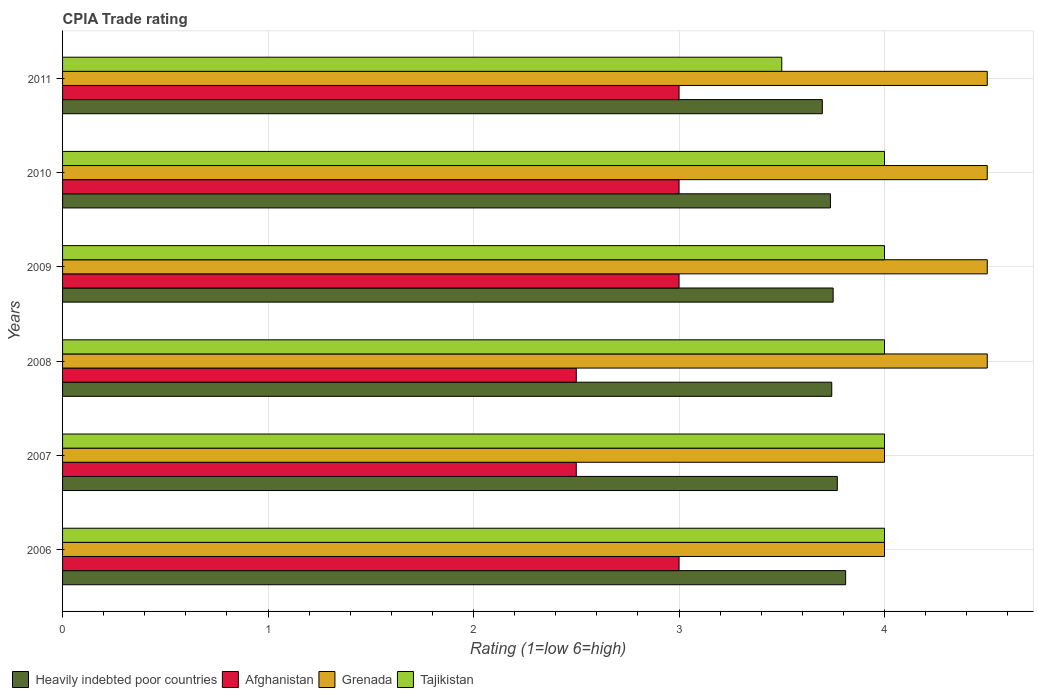How many different coloured bars are there?
Offer a very short reply. 4. How many groups of bars are there?
Your answer should be very brief. 6. Are the number of bars per tick equal to the number of legend labels?
Provide a succinct answer. Yes. How many bars are there on the 2nd tick from the top?
Your response must be concise. 4. What is the label of the 2nd group of bars from the top?
Give a very brief answer. 2010. In how many cases, is the number of bars for a given year not equal to the number of legend labels?
Your answer should be compact. 0. What is the CPIA rating in Tajikistan in 2011?
Your answer should be very brief. 3.5. Across all years, what is the maximum CPIA rating in Heavily indebted poor countries?
Give a very brief answer. 3.81. In which year was the CPIA rating in Afghanistan maximum?
Give a very brief answer. 2006. What is the total CPIA rating in Heavily indebted poor countries in the graph?
Your answer should be very brief. 22.51. What is the difference between the CPIA rating in Heavily indebted poor countries in 2010 and the CPIA rating in Tajikistan in 2011?
Your answer should be very brief. 0.24. What is the average CPIA rating in Heavily indebted poor countries per year?
Your answer should be compact. 3.75. In the year 2008, what is the difference between the CPIA rating in Afghanistan and CPIA rating in Grenada?
Your answer should be compact. -2. In how many years, is the CPIA rating in Tajikistan greater than 0.2 ?
Provide a short and direct response. 6. What is the ratio of the CPIA rating in Grenada in 2009 to that in 2010?
Keep it short and to the point. 1. Is the CPIA rating in Heavily indebted poor countries in 2006 less than that in 2010?
Your answer should be very brief. No. What is the difference between the highest and the second highest CPIA rating in Grenada?
Make the answer very short. 0. What is the difference between the highest and the lowest CPIA rating in Grenada?
Your answer should be compact. 0.5. In how many years, is the CPIA rating in Heavily indebted poor countries greater than the average CPIA rating in Heavily indebted poor countries taken over all years?
Your answer should be compact. 2. Is the sum of the CPIA rating in Heavily indebted poor countries in 2008 and 2010 greater than the maximum CPIA rating in Grenada across all years?
Give a very brief answer. Yes. Is it the case that in every year, the sum of the CPIA rating in Heavily indebted poor countries and CPIA rating in Afghanistan is greater than the sum of CPIA rating in Tajikistan and CPIA rating in Grenada?
Offer a very short reply. No. What does the 1st bar from the top in 2008 represents?
Make the answer very short. Tajikistan. What does the 2nd bar from the bottom in 2007 represents?
Ensure brevity in your answer.  Afghanistan. Is it the case that in every year, the sum of the CPIA rating in Afghanistan and CPIA rating in Grenada is greater than the CPIA rating in Heavily indebted poor countries?
Provide a short and direct response. Yes. How many bars are there?
Offer a terse response. 24. Are all the bars in the graph horizontal?
Your response must be concise. Yes. What is the difference between two consecutive major ticks on the X-axis?
Offer a very short reply. 1. Does the graph contain grids?
Provide a succinct answer. Yes. Where does the legend appear in the graph?
Your answer should be very brief. Bottom left. How are the legend labels stacked?
Keep it short and to the point. Horizontal. What is the title of the graph?
Offer a very short reply. CPIA Trade rating. What is the label or title of the X-axis?
Keep it short and to the point. Rating (1=low 6=high). What is the Rating (1=low 6=high) of Heavily indebted poor countries in 2006?
Your answer should be very brief. 3.81. What is the Rating (1=low 6=high) in Afghanistan in 2006?
Offer a very short reply. 3. What is the Rating (1=low 6=high) in Grenada in 2006?
Offer a very short reply. 4. What is the Rating (1=low 6=high) of Tajikistan in 2006?
Offer a terse response. 4. What is the Rating (1=low 6=high) in Heavily indebted poor countries in 2007?
Ensure brevity in your answer.  3.77. What is the Rating (1=low 6=high) of Grenada in 2007?
Provide a short and direct response. 4. What is the Rating (1=low 6=high) in Heavily indebted poor countries in 2008?
Give a very brief answer. 3.74. What is the Rating (1=low 6=high) of Heavily indebted poor countries in 2009?
Ensure brevity in your answer.  3.75. What is the Rating (1=low 6=high) of Afghanistan in 2009?
Your answer should be very brief. 3. What is the Rating (1=low 6=high) of Grenada in 2009?
Make the answer very short. 4.5. What is the Rating (1=low 6=high) of Heavily indebted poor countries in 2010?
Ensure brevity in your answer.  3.74. What is the Rating (1=low 6=high) of Afghanistan in 2010?
Offer a terse response. 3. What is the Rating (1=low 6=high) in Tajikistan in 2010?
Your answer should be very brief. 4. What is the Rating (1=low 6=high) in Heavily indebted poor countries in 2011?
Your answer should be compact. 3.7. What is the Rating (1=low 6=high) of Afghanistan in 2011?
Offer a terse response. 3. What is the Rating (1=low 6=high) in Grenada in 2011?
Offer a very short reply. 4.5. Across all years, what is the maximum Rating (1=low 6=high) of Heavily indebted poor countries?
Give a very brief answer. 3.81. Across all years, what is the minimum Rating (1=low 6=high) in Heavily indebted poor countries?
Your answer should be very brief. 3.7. Across all years, what is the minimum Rating (1=low 6=high) of Afghanistan?
Make the answer very short. 2.5. Across all years, what is the minimum Rating (1=low 6=high) of Tajikistan?
Ensure brevity in your answer.  3.5. What is the total Rating (1=low 6=high) of Heavily indebted poor countries in the graph?
Give a very brief answer. 22.51. What is the total Rating (1=low 6=high) in Grenada in the graph?
Offer a very short reply. 26. What is the difference between the Rating (1=low 6=high) in Heavily indebted poor countries in 2006 and that in 2007?
Provide a short and direct response. 0.04. What is the difference between the Rating (1=low 6=high) of Tajikistan in 2006 and that in 2007?
Provide a succinct answer. 0. What is the difference between the Rating (1=low 6=high) of Heavily indebted poor countries in 2006 and that in 2008?
Offer a terse response. 0.07. What is the difference between the Rating (1=low 6=high) in Grenada in 2006 and that in 2008?
Make the answer very short. -0.5. What is the difference between the Rating (1=low 6=high) in Heavily indebted poor countries in 2006 and that in 2009?
Your response must be concise. 0.06. What is the difference between the Rating (1=low 6=high) of Grenada in 2006 and that in 2009?
Your response must be concise. -0.5. What is the difference between the Rating (1=low 6=high) in Heavily indebted poor countries in 2006 and that in 2010?
Your response must be concise. 0.07. What is the difference between the Rating (1=low 6=high) of Afghanistan in 2006 and that in 2010?
Keep it short and to the point. 0. What is the difference between the Rating (1=low 6=high) of Heavily indebted poor countries in 2006 and that in 2011?
Offer a terse response. 0.11. What is the difference between the Rating (1=low 6=high) of Tajikistan in 2006 and that in 2011?
Give a very brief answer. 0.5. What is the difference between the Rating (1=low 6=high) in Heavily indebted poor countries in 2007 and that in 2008?
Offer a very short reply. 0.03. What is the difference between the Rating (1=low 6=high) of Tajikistan in 2007 and that in 2008?
Your answer should be very brief. 0. What is the difference between the Rating (1=low 6=high) in Heavily indebted poor countries in 2007 and that in 2009?
Your answer should be compact. 0.02. What is the difference between the Rating (1=low 6=high) of Tajikistan in 2007 and that in 2009?
Make the answer very short. 0. What is the difference between the Rating (1=low 6=high) of Heavily indebted poor countries in 2007 and that in 2010?
Your answer should be compact. 0.03. What is the difference between the Rating (1=low 6=high) in Afghanistan in 2007 and that in 2010?
Offer a very short reply. -0.5. What is the difference between the Rating (1=low 6=high) of Grenada in 2007 and that in 2010?
Offer a terse response. -0.5. What is the difference between the Rating (1=low 6=high) in Heavily indebted poor countries in 2007 and that in 2011?
Ensure brevity in your answer.  0.07. What is the difference between the Rating (1=low 6=high) of Heavily indebted poor countries in 2008 and that in 2009?
Keep it short and to the point. -0.01. What is the difference between the Rating (1=low 6=high) in Tajikistan in 2008 and that in 2009?
Ensure brevity in your answer.  0. What is the difference between the Rating (1=low 6=high) of Heavily indebted poor countries in 2008 and that in 2010?
Offer a very short reply. 0.01. What is the difference between the Rating (1=low 6=high) in Afghanistan in 2008 and that in 2010?
Give a very brief answer. -0.5. What is the difference between the Rating (1=low 6=high) of Tajikistan in 2008 and that in 2010?
Keep it short and to the point. 0. What is the difference between the Rating (1=low 6=high) of Heavily indebted poor countries in 2008 and that in 2011?
Offer a terse response. 0.05. What is the difference between the Rating (1=low 6=high) of Grenada in 2008 and that in 2011?
Keep it short and to the point. 0. What is the difference between the Rating (1=low 6=high) in Tajikistan in 2008 and that in 2011?
Your response must be concise. 0.5. What is the difference between the Rating (1=low 6=high) of Heavily indebted poor countries in 2009 and that in 2010?
Provide a succinct answer. 0.01. What is the difference between the Rating (1=low 6=high) of Afghanistan in 2009 and that in 2010?
Offer a very short reply. 0. What is the difference between the Rating (1=low 6=high) of Grenada in 2009 and that in 2010?
Give a very brief answer. 0. What is the difference between the Rating (1=low 6=high) of Heavily indebted poor countries in 2009 and that in 2011?
Offer a very short reply. 0.05. What is the difference between the Rating (1=low 6=high) of Grenada in 2009 and that in 2011?
Give a very brief answer. 0. What is the difference between the Rating (1=low 6=high) in Tajikistan in 2009 and that in 2011?
Make the answer very short. 0.5. What is the difference between the Rating (1=low 6=high) of Heavily indebted poor countries in 2010 and that in 2011?
Your answer should be compact. 0.04. What is the difference between the Rating (1=low 6=high) of Heavily indebted poor countries in 2006 and the Rating (1=low 6=high) of Afghanistan in 2007?
Offer a terse response. 1.31. What is the difference between the Rating (1=low 6=high) of Heavily indebted poor countries in 2006 and the Rating (1=low 6=high) of Grenada in 2007?
Your answer should be compact. -0.19. What is the difference between the Rating (1=low 6=high) of Heavily indebted poor countries in 2006 and the Rating (1=low 6=high) of Tajikistan in 2007?
Make the answer very short. -0.19. What is the difference between the Rating (1=low 6=high) of Afghanistan in 2006 and the Rating (1=low 6=high) of Tajikistan in 2007?
Your answer should be compact. -1. What is the difference between the Rating (1=low 6=high) of Grenada in 2006 and the Rating (1=low 6=high) of Tajikistan in 2007?
Keep it short and to the point. 0. What is the difference between the Rating (1=low 6=high) in Heavily indebted poor countries in 2006 and the Rating (1=low 6=high) in Afghanistan in 2008?
Your answer should be very brief. 1.31. What is the difference between the Rating (1=low 6=high) in Heavily indebted poor countries in 2006 and the Rating (1=low 6=high) in Grenada in 2008?
Your answer should be very brief. -0.69. What is the difference between the Rating (1=low 6=high) in Heavily indebted poor countries in 2006 and the Rating (1=low 6=high) in Tajikistan in 2008?
Keep it short and to the point. -0.19. What is the difference between the Rating (1=low 6=high) of Afghanistan in 2006 and the Rating (1=low 6=high) of Tajikistan in 2008?
Your answer should be compact. -1. What is the difference between the Rating (1=low 6=high) of Heavily indebted poor countries in 2006 and the Rating (1=low 6=high) of Afghanistan in 2009?
Your answer should be compact. 0.81. What is the difference between the Rating (1=low 6=high) in Heavily indebted poor countries in 2006 and the Rating (1=low 6=high) in Grenada in 2009?
Ensure brevity in your answer.  -0.69. What is the difference between the Rating (1=low 6=high) of Heavily indebted poor countries in 2006 and the Rating (1=low 6=high) of Tajikistan in 2009?
Keep it short and to the point. -0.19. What is the difference between the Rating (1=low 6=high) in Afghanistan in 2006 and the Rating (1=low 6=high) in Grenada in 2009?
Offer a terse response. -1.5. What is the difference between the Rating (1=low 6=high) in Afghanistan in 2006 and the Rating (1=low 6=high) in Tajikistan in 2009?
Make the answer very short. -1. What is the difference between the Rating (1=low 6=high) in Grenada in 2006 and the Rating (1=low 6=high) in Tajikistan in 2009?
Make the answer very short. 0. What is the difference between the Rating (1=low 6=high) in Heavily indebted poor countries in 2006 and the Rating (1=low 6=high) in Afghanistan in 2010?
Offer a terse response. 0.81. What is the difference between the Rating (1=low 6=high) in Heavily indebted poor countries in 2006 and the Rating (1=low 6=high) in Grenada in 2010?
Provide a succinct answer. -0.69. What is the difference between the Rating (1=low 6=high) in Heavily indebted poor countries in 2006 and the Rating (1=low 6=high) in Tajikistan in 2010?
Offer a very short reply. -0.19. What is the difference between the Rating (1=low 6=high) in Heavily indebted poor countries in 2006 and the Rating (1=low 6=high) in Afghanistan in 2011?
Keep it short and to the point. 0.81. What is the difference between the Rating (1=low 6=high) in Heavily indebted poor countries in 2006 and the Rating (1=low 6=high) in Grenada in 2011?
Ensure brevity in your answer.  -0.69. What is the difference between the Rating (1=low 6=high) in Heavily indebted poor countries in 2006 and the Rating (1=low 6=high) in Tajikistan in 2011?
Your answer should be compact. 0.31. What is the difference between the Rating (1=low 6=high) in Afghanistan in 2006 and the Rating (1=low 6=high) in Tajikistan in 2011?
Make the answer very short. -0.5. What is the difference between the Rating (1=low 6=high) of Heavily indebted poor countries in 2007 and the Rating (1=low 6=high) of Afghanistan in 2008?
Ensure brevity in your answer.  1.27. What is the difference between the Rating (1=low 6=high) of Heavily indebted poor countries in 2007 and the Rating (1=low 6=high) of Grenada in 2008?
Your answer should be very brief. -0.73. What is the difference between the Rating (1=low 6=high) of Heavily indebted poor countries in 2007 and the Rating (1=low 6=high) of Tajikistan in 2008?
Keep it short and to the point. -0.23. What is the difference between the Rating (1=low 6=high) in Afghanistan in 2007 and the Rating (1=low 6=high) in Grenada in 2008?
Provide a short and direct response. -2. What is the difference between the Rating (1=low 6=high) of Heavily indebted poor countries in 2007 and the Rating (1=low 6=high) of Afghanistan in 2009?
Provide a short and direct response. 0.77. What is the difference between the Rating (1=low 6=high) of Heavily indebted poor countries in 2007 and the Rating (1=low 6=high) of Grenada in 2009?
Your answer should be compact. -0.73. What is the difference between the Rating (1=low 6=high) of Heavily indebted poor countries in 2007 and the Rating (1=low 6=high) of Tajikistan in 2009?
Your answer should be compact. -0.23. What is the difference between the Rating (1=low 6=high) in Heavily indebted poor countries in 2007 and the Rating (1=low 6=high) in Afghanistan in 2010?
Provide a succinct answer. 0.77. What is the difference between the Rating (1=low 6=high) of Heavily indebted poor countries in 2007 and the Rating (1=low 6=high) of Grenada in 2010?
Make the answer very short. -0.73. What is the difference between the Rating (1=low 6=high) of Heavily indebted poor countries in 2007 and the Rating (1=low 6=high) of Tajikistan in 2010?
Provide a short and direct response. -0.23. What is the difference between the Rating (1=low 6=high) in Afghanistan in 2007 and the Rating (1=low 6=high) in Tajikistan in 2010?
Your response must be concise. -1.5. What is the difference between the Rating (1=low 6=high) in Heavily indebted poor countries in 2007 and the Rating (1=low 6=high) in Afghanistan in 2011?
Your answer should be compact. 0.77. What is the difference between the Rating (1=low 6=high) in Heavily indebted poor countries in 2007 and the Rating (1=low 6=high) in Grenada in 2011?
Your answer should be compact. -0.73. What is the difference between the Rating (1=low 6=high) of Heavily indebted poor countries in 2007 and the Rating (1=low 6=high) of Tajikistan in 2011?
Provide a short and direct response. 0.27. What is the difference between the Rating (1=low 6=high) of Afghanistan in 2007 and the Rating (1=low 6=high) of Tajikistan in 2011?
Give a very brief answer. -1. What is the difference between the Rating (1=low 6=high) in Grenada in 2007 and the Rating (1=low 6=high) in Tajikistan in 2011?
Give a very brief answer. 0.5. What is the difference between the Rating (1=low 6=high) in Heavily indebted poor countries in 2008 and the Rating (1=low 6=high) in Afghanistan in 2009?
Your answer should be compact. 0.74. What is the difference between the Rating (1=low 6=high) in Heavily indebted poor countries in 2008 and the Rating (1=low 6=high) in Grenada in 2009?
Offer a very short reply. -0.76. What is the difference between the Rating (1=low 6=high) in Heavily indebted poor countries in 2008 and the Rating (1=low 6=high) in Tajikistan in 2009?
Your answer should be very brief. -0.26. What is the difference between the Rating (1=low 6=high) in Afghanistan in 2008 and the Rating (1=low 6=high) in Grenada in 2009?
Your answer should be very brief. -2. What is the difference between the Rating (1=low 6=high) of Afghanistan in 2008 and the Rating (1=low 6=high) of Tajikistan in 2009?
Provide a short and direct response. -1.5. What is the difference between the Rating (1=low 6=high) in Heavily indebted poor countries in 2008 and the Rating (1=low 6=high) in Afghanistan in 2010?
Give a very brief answer. 0.74. What is the difference between the Rating (1=low 6=high) of Heavily indebted poor countries in 2008 and the Rating (1=low 6=high) of Grenada in 2010?
Make the answer very short. -0.76. What is the difference between the Rating (1=low 6=high) of Heavily indebted poor countries in 2008 and the Rating (1=low 6=high) of Tajikistan in 2010?
Offer a very short reply. -0.26. What is the difference between the Rating (1=low 6=high) in Afghanistan in 2008 and the Rating (1=low 6=high) in Grenada in 2010?
Make the answer very short. -2. What is the difference between the Rating (1=low 6=high) of Heavily indebted poor countries in 2008 and the Rating (1=low 6=high) of Afghanistan in 2011?
Offer a very short reply. 0.74. What is the difference between the Rating (1=low 6=high) of Heavily indebted poor countries in 2008 and the Rating (1=low 6=high) of Grenada in 2011?
Keep it short and to the point. -0.76. What is the difference between the Rating (1=low 6=high) of Heavily indebted poor countries in 2008 and the Rating (1=low 6=high) of Tajikistan in 2011?
Ensure brevity in your answer.  0.24. What is the difference between the Rating (1=low 6=high) of Afghanistan in 2008 and the Rating (1=low 6=high) of Grenada in 2011?
Ensure brevity in your answer.  -2. What is the difference between the Rating (1=low 6=high) in Heavily indebted poor countries in 2009 and the Rating (1=low 6=high) in Grenada in 2010?
Make the answer very short. -0.75. What is the difference between the Rating (1=low 6=high) of Heavily indebted poor countries in 2009 and the Rating (1=low 6=high) of Tajikistan in 2010?
Your answer should be compact. -0.25. What is the difference between the Rating (1=low 6=high) of Afghanistan in 2009 and the Rating (1=low 6=high) of Tajikistan in 2010?
Make the answer very short. -1. What is the difference between the Rating (1=low 6=high) of Grenada in 2009 and the Rating (1=low 6=high) of Tajikistan in 2010?
Ensure brevity in your answer.  0.5. What is the difference between the Rating (1=low 6=high) in Heavily indebted poor countries in 2009 and the Rating (1=low 6=high) in Afghanistan in 2011?
Your answer should be very brief. 0.75. What is the difference between the Rating (1=low 6=high) of Heavily indebted poor countries in 2009 and the Rating (1=low 6=high) of Grenada in 2011?
Your answer should be very brief. -0.75. What is the difference between the Rating (1=low 6=high) in Heavily indebted poor countries in 2009 and the Rating (1=low 6=high) in Tajikistan in 2011?
Offer a very short reply. 0.25. What is the difference between the Rating (1=low 6=high) of Grenada in 2009 and the Rating (1=low 6=high) of Tajikistan in 2011?
Give a very brief answer. 1. What is the difference between the Rating (1=low 6=high) in Heavily indebted poor countries in 2010 and the Rating (1=low 6=high) in Afghanistan in 2011?
Make the answer very short. 0.74. What is the difference between the Rating (1=low 6=high) in Heavily indebted poor countries in 2010 and the Rating (1=low 6=high) in Grenada in 2011?
Your response must be concise. -0.76. What is the difference between the Rating (1=low 6=high) in Heavily indebted poor countries in 2010 and the Rating (1=low 6=high) in Tajikistan in 2011?
Offer a very short reply. 0.24. What is the difference between the Rating (1=low 6=high) of Afghanistan in 2010 and the Rating (1=low 6=high) of Tajikistan in 2011?
Keep it short and to the point. -0.5. What is the difference between the Rating (1=low 6=high) in Grenada in 2010 and the Rating (1=low 6=high) in Tajikistan in 2011?
Make the answer very short. 1. What is the average Rating (1=low 6=high) in Heavily indebted poor countries per year?
Give a very brief answer. 3.75. What is the average Rating (1=low 6=high) in Afghanistan per year?
Ensure brevity in your answer.  2.83. What is the average Rating (1=low 6=high) of Grenada per year?
Provide a short and direct response. 4.33. What is the average Rating (1=low 6=high) of Tajikistan per year?
Your answer should be very brief. 3.92. In the year 2006, what is the difference between the Rating (1=low 6=high) of Heavily indebted poor countries and Rating (1=low 6=high) of Afghanistan?
Make the answer very short. 0.81. In the year 2006, what is the difference between the Rating (1=low 6=high) of Heavily indebted poor countries and Rating (1=low 6=high) of Grenada?
Provide a succinct answer. -0.19. In the year 2006, what is the difference between the Rating (1=low 6=high) of Heavily indebted poor countries and Rating (1=low 6=high) of Tajikistan?
Your response must be concise. -0.19. In the year 2006, what is the difference between the Rating (1=low 6=high) of Afghanistan and Rating (1=low 6=high) of Tajikistan?
Make the answer very short. -1. In the year 2007, what is the difference between the Rating (1=low 6=high) in Heavily indebted poor countries and Rating (1=low 6=high) in Afghanistan?
Keep it short and to the point. 1.27. In the year 2007, what is the difference between the Rating (1=low 6=high) of Heavily indebted poor countries and Rating (1=low 6=high) of Grenada?
Provide a succinct answer. -0.23. In the year 2007, what is the difference between the Rating (1=low 6=high) of Heavily indebted poor countries and Rating (1=low 6=high) of Tajikistan?
Make the answer very short. -0.23. In the year 2007, what is the difference between the Rating (1=low 6=high) of Afghanistan and Rating (1=low 6=high) of Tajikistan?
Provide a succinct answer. -1.5. In the year 2007, what is the difference between the Rating (1=low 6=high) of Grenada and Rating (1=low 6=high) of Tajikistan?
Make the answer very short. 0. In the year 2008, what is the difference between the Rating (1=low 6=high) in Heavily indebted poor countries and Rating (1=low 6=high) in Afghanistan?
Ensure brevity in your answer.  1.24. In the year 2008, what is the difference between the Rating (1=low 6=high) in Heavily indebted poor countries and Rating (1=low 6=high) in Grenada?
Offer a very short reply. -0.76. In the year 2008, what is the difference between the Rating (1=low 6=high) in Heavily indebted poor countries and Rating (1=low 6=high) in Tajikistan?
Offer a terse response. -0.26. In the year 2009, what is the difference between the Rating (1=low 6=high) in Heavily indebted poor countries and Rating (1=low 6=high) in Grenada?
Keep it short and to the point. -0.75. In the year 2009, what is the difference between the Rating (1=low 6=high) in Heavily indebted poor countries and Rating (1=low 6=high) in Tajikistan?
Keep it short and to the point. -0.25. In the year 2009, what is the difference between the Rating (1=low 6=high) of Afghanistan and Rating (1=low 6=high) of Grenada?
Your answer should be very brief. -1.5. In the year 2009, what is the difference between the Rating (1=low 6=high) of Afghanistan and Rating (1=low 6=high) of Tajikistan?
Your answer should be very brief. -1. In the year 2010, what is the difference between the Rating (1=low 6=high) in Heavily indebted poor countries and Rating (1=low 6=high) in Afghanistan?
Offer a very short reply. 0.74. In the year 2010, what is the difference between the Rating (1=low 6=high) in Heavily indebted poor countries and Rating (1=low 6=high) in Grenada?
Offer a very short reply. -0.76. In the year 2010, what is the difference between the Rating (1=low 6=high) in Heavily indebted poor countries and Rating (1=low 6=high) in Tajikistan?
Keep it short and to the point. -0.26. In the year 2010, what is the difference between the Rating (1=low 6=high) of Afghanistan and Rating (1=low 6=high) of Grenada?
Your answer should be very brief. -1.5. In the year 2011, what is the difference between the Rating (1=low 6=high) of Heavily indebted poor countries and Rating (1=low 6=high) of Afghanistan?
Make the answer very short. 0.7. In the year 2011, what is the difference between the Rating (1=low 6=high) of Heavily indebted poor countries and Rating (1=low 6=high) of Grenada?
Offer a terse response. -0.8. In the year 2011, what is the difference between the Rating (1=low 6=high) in Heavily indebted poor countries and Rating (1=low 6=high) in Tajikistan?
Provide a succinct answer. 0.2. In the year 2011, what is the difference between the Rating (1=low 6=high) of Afghanistan and Rating (1=low 6=high) of Tajikistan?
Ensure brevity in your answer.  -0.5. What is the ratio of the Rating (1=low 6=high) of Heavily indebted poor countries in 2006 to that in 2007?
Provide a succinct answer. 1.01. What is the ratio of the Rating (1=low 6=high) in Afghanistan in 2006 to that in 2007?
Ensure brevity in your answer.  1.2. What is the ratio of the Rating (1=low 6=high) in Tajikistan in 2006 to that in 2007?
Your answer should be compact. 1. What is the ratio of the Rating (1=low 6=high) of Heavily indebted poor countries in 2006 to that in 2008?
Keep it short and to the point. 1.02. What is the ratio of the Rating (1=low 6=high) in Heavily indebted poor countries in 2006 to that in 2009?
Your answer should be compact. 1.02. What is the ratio of the Rating (1=low 6=high) of Afghanistan in 2006 to that in 2009?
Keep it short and to the point. 1. What is the ratio of the Rating (1=low 6=high) of Grenada in 2006 to that in 2009?
Your answer should be very brief. 0.89. What is the ratio of the Rating (1=low 6=high) in Tajikistan in 2006 to that in 2009?
Make the answer very short. 1. What is the ratio of the Rating (1=low 6=high) in Heavily indebted poor countries in 2006 to that in 2010?
Ensure brevity in your answer.  1.02. What is the ratio of the Rating (1=low 6=high) of Grenada in 2006 to that in 2010?
Give a very brief answer. 0.89. What is the ratio of the Rating (1=low 6=high) in Heavily indebted poor countries in 2006 to that in 2011?
Keep it short and to the point. 1.03. What is the ratio of the Rating (1=low 6=high) of Grenada in 2006 to that in 2011?
Offer a very short reply. 0.89. What is the ratio of the Rating (1=low 6=high) in Tajikistan in 2006 to that in 2011?
Your answer should be compact. 1.14. What is the ratio of the Rating (1=low 6=high) of Grenada in 2007 to that in 2008?
Your answer should be very brief. 0.89. What is the ratio of the Rating (1=low 6=high) in Heavily indebted poor countries in 2007 to that in 2009?
Keep it short and to the point. 1.01. What is the ratio of the Rating (1=low 6=high) of Afghanistan in 2007 to that in 2009?
Give a very brief answer. 0.83. What is the ratio of the Rating (1=low 6=high) in Tajikistan in 2007 to that in 2009?
Your answer should be compact. 1. What is the ratio of the Rating (1=low 6=high) in Heavily indebted poor countries in 2007 to that in 2010?
Provide a short and direct response. 1.01. What is the ratio of the Rating (1=low 6=high) of Heavily indebted poor countries in 2007 to that in 2011?
Ensure brevity in your answer.  1.02. What is the ratio of the Rating (1=low 6=high) in Afghanistan in 2007 to that in 2011?
Your response must be concise. 0.83. What is the ratio of the Rating (1=low 6=high) of Grenada in 2008 to that in 2009?
Your response must be concise. 1. What is the ratio of the Rating (1=low 6=high) in Tajikistan in 2008 to that in 2009?
Your response must be concise. 1. What is the ratio of the Rating (1=low 6=high) of Grenada in 2008 to that in 2010?
Make the answer very short. 1. What is the ratio of the Rating (1=low 6=high) in Tajikistan in 2008 to that in 2010?
Your response must be concise. 1. What is the ratio of the Rating (1=low 6=high) in Heavily indebted poor countries in 2008 to that in 2011?
Your answer should be very brief. 1.01. What is the ratio of the Rating (1=low 6=high) in Afghanistan in 2008 to that in 2011?
Your response must be concise. 0.83. What is the ratio of the Rating (1=low 6=high) in Grenada in 2008 to that in 2011?
Offer a terse response. 1. What is the ratio of the Rating (1=low 6=high) in Tajikistan in 2008 to that in 2011?
Make the answer very short. 1.14. What is the ratio of the Rating (1=low 6=high) in Heavily indebted poor countries in 2009 to that in 2010?
Make the answer very short. 1. What is the ratio of the Rating (1=low 6=high) in Afghanistan in 2009 to that in 2010?
Make the answer very short. 1. What is the ratio of the Rating (1=low 6=high) of Grenada in 2009 to that in 2010?
Offer a very short reply. 1. What is the ratio of the Rating (1=low 6=high) of Tajikistan in 2009 to that in 2010?
Offer a very short reply. 1. What is the ratio of the Rating (1=low 6=high) of Heavily indebted poor countries in 2009 to that in 2011?
Keep it short and to the point. 1.01. What is the ratio of the Rating (1=low 6=high) of Heavily indebted poor countries in 2010 to that in 2011?
Provide a succinct answer. 1.01. What is the ratio of the Rating (1=low 6=high) of Grenada in 2010 to that in 2011?
Make the answer very short. 1. What is the ratio of the Rating (1=low 6=high) of Tajikistan in 2010 to that in 2011?
Offer a terse response. 1.14. What is the difference between the highest and the second highest Rating (1=low 6=high) of Heavily indebted poor countries?
Provide a succinct answer. 0.04. What is the difference between the highest and the second highest Rating (1=low 6=high) of Grenada?
Give a very brief answer. 0. What is the difference between the highest and the second highest Rating (1=low 6=high) of Tajikistan?
Provide a short and direct response. 0. What is the difference between the highest and the lowest Rating (1=low 6=high) of Heavily indebted poor countries?
Provide a short and direct response. 0.11. What is the difference between the highest and the lowest Rating (1=low 6=high) in Afghanistan?
Offer a terse response. 0.5. What is the difference between the highest and the lowest Rating (1=low 6=high) in Tajikistan?
Keep it short and to the point. 0.5. 